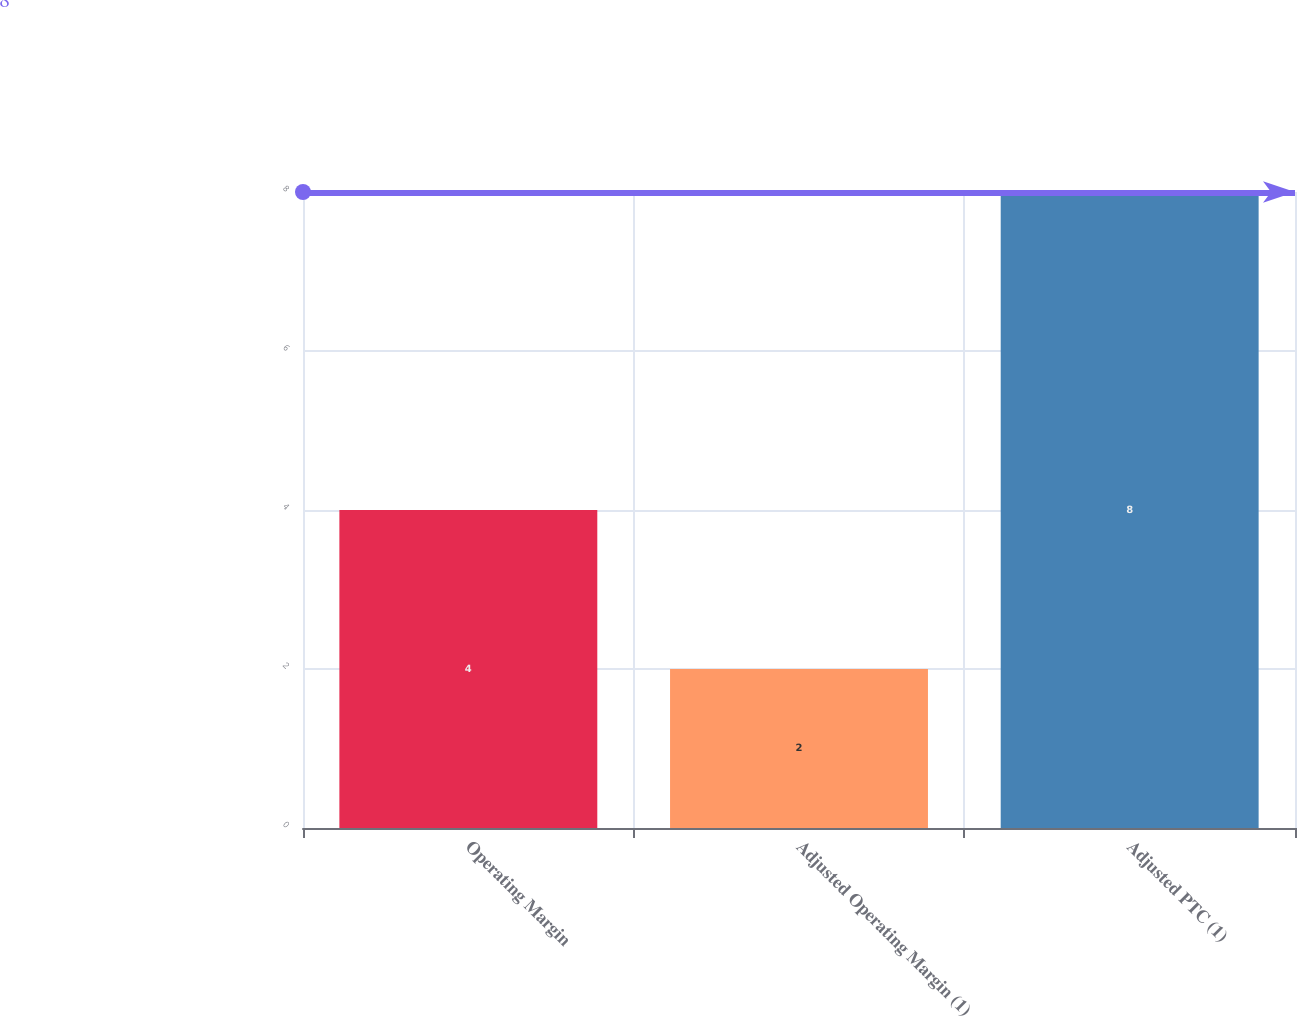<chart> <loc_0><loc_0><loc_500><loc_500><bar_chart><fcel>Operating Margin<fcel>Adjusted Operating Margin (1)<fcel>Adjusted PTC (1)<nl><fcel>4<fcel>2<fcel>8<nl></chart> 